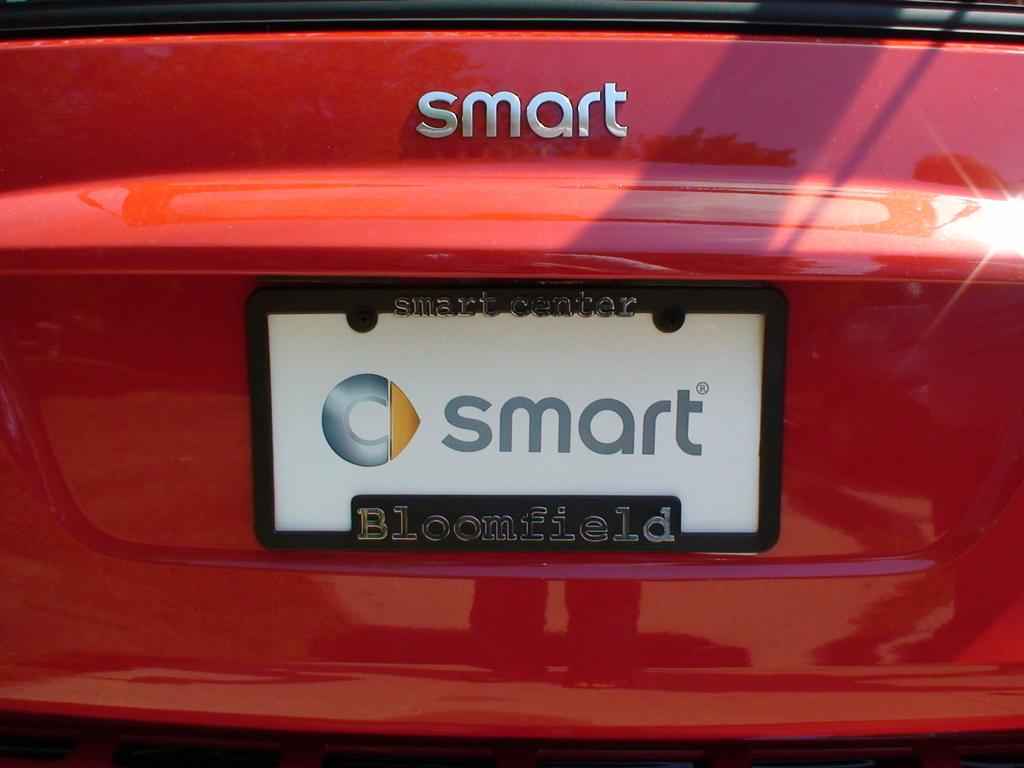What brand of car?
Provide a succinct answer. Smart. What does the license plate say?
Offer a terse response. Smart. 